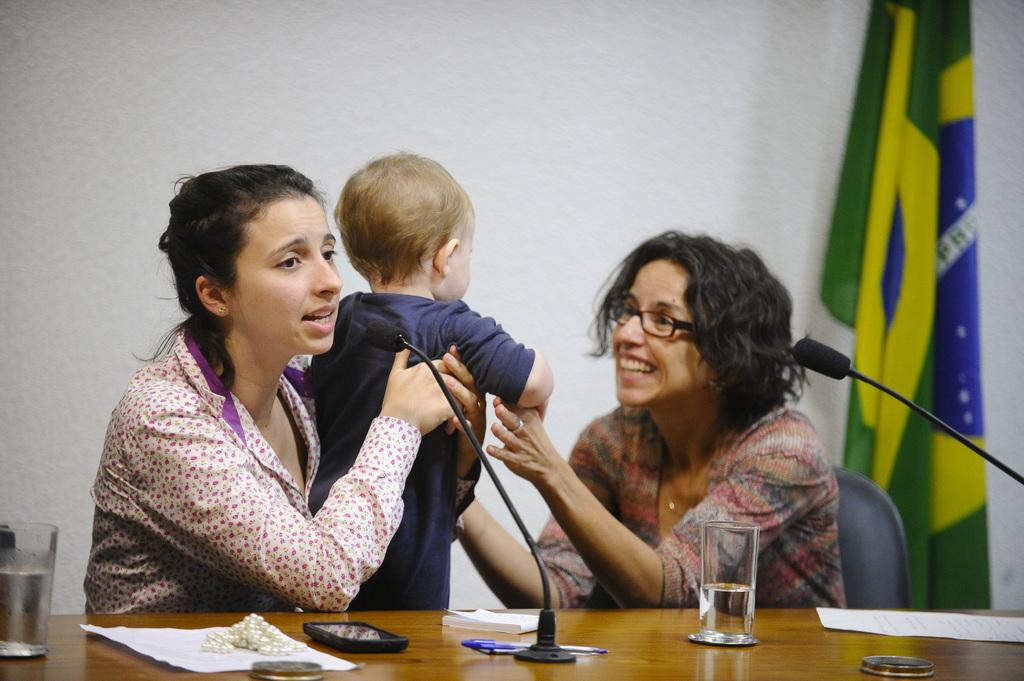How many individuals are present in the image? There are two people and a kid in the image. What are the people and the kid doing in the image? They are sitting in front of a table. What objects can be seen on the table? There are mics, paper, glasses, and other unspecified objects on the table. What is the weight of the clam on the table in the image? There is no clam present on the table in the image. What type of secretary is sitting next to the kid in the image? There is no secretary present in the image; it only shows two people and a kid sitting in front of a table. 